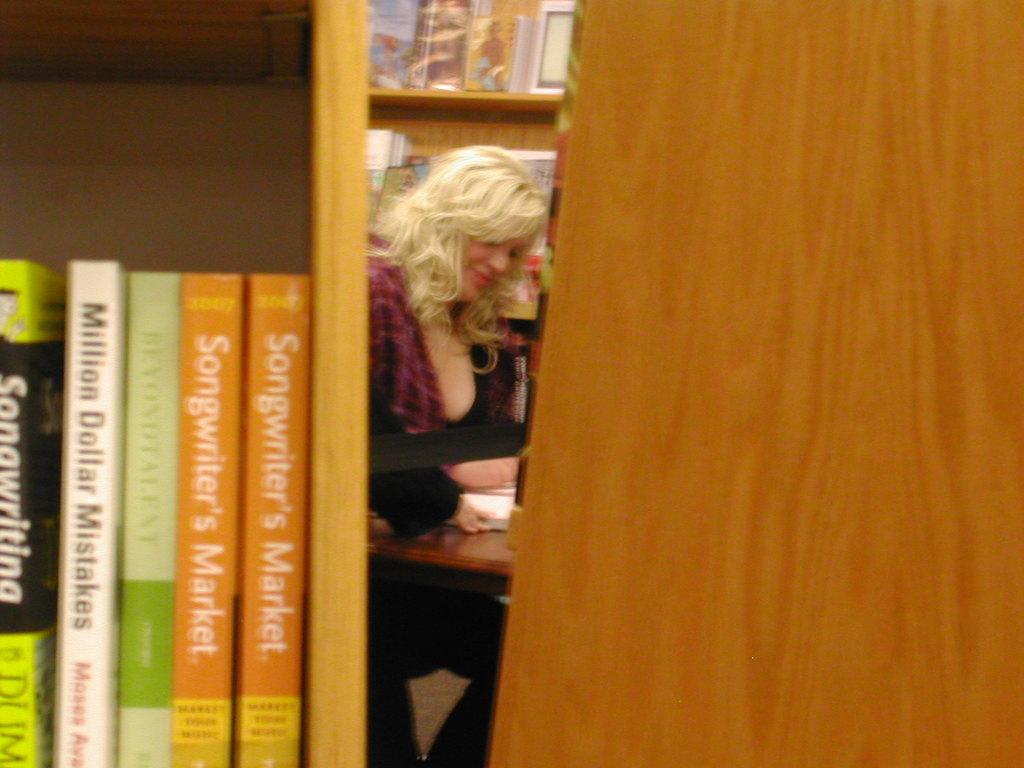Who is present in the image? There is a woman in the image. What is in front of the woman? There is a table in front of the woman. What items can be seen on the table? There are books on the table. What other object is visible in the image? There is a rack in the image. What type of apparel is the woman wearing in the image? The provided facts do not mention any apparel worn by the woman, so we cannot determine her clothing from the image. What color is the lamp on the table in the image? There is no lamp present on the table in the image. 